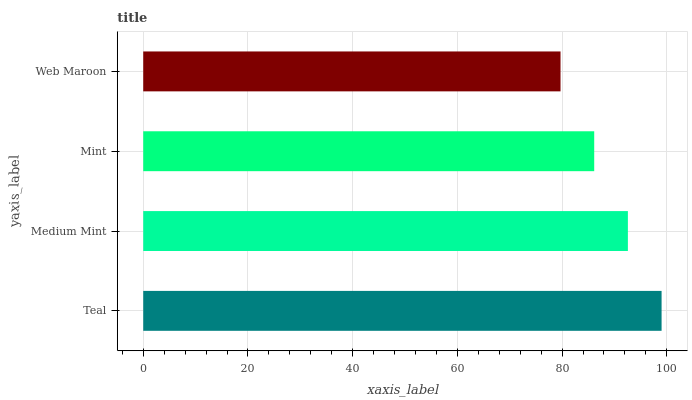Is Web Maroon the minimum?
Answer yes or no. Yes. Is Teal the maximum?
Answer yes or no. Yes. Is Medium Mint the minimum?
Answer yes or no. No. Is Medium Mint the maximum?
Answer yes or no. No. Is Teal greater than Medium Mint?
Answer yes or no. Yes. Is Medium Mint less than Teal?
Answer yes or no. Yes. Is Medium Mint greater than Teal?
Answer yes or no. No. Is Teal less than Medium Mint?
Answer yes or no. No. Is Medium Mint the high median?
Answer yes or no. Yes. Is Mint the low median?
Answer yes or no. Yes. Is Teal the high median?
Answer yes or no. No. Is Web Maroon the low median?
Answer yes or no. No. 